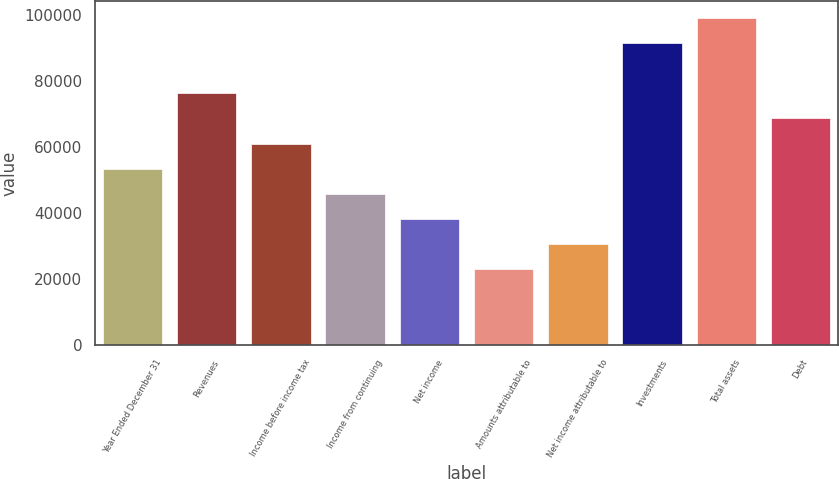<chart> <loc_0><loc_0><loc_500><loc_500><bar_chart><fcel>Year Ended December 31<fcel>Revenues<fcel>Income before income tax<fcel>Income from continuing<fcel>Net income<fcel>Amounts attributable to<fcel>Net income attributable to<fcel>Investments<fcel>Total assets<fcel>Debt<nl><fcel>53338.7<fcel>76198<fcel>60958.5<fcel>45718.9<fcel>38099.1<fcel>22859.6<fcel>30479.4<fcel>91437.6<fcel>99057.3<fcel>68578.2<nl></chart> 